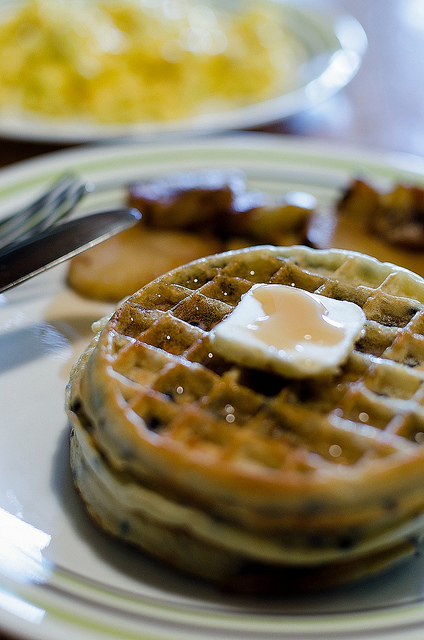<image>What meal does this indicate? It is not clear what meal this indicates, but it could be breakfast. What meal does this indicate? This indicates that the meal is most likely breakfast. 